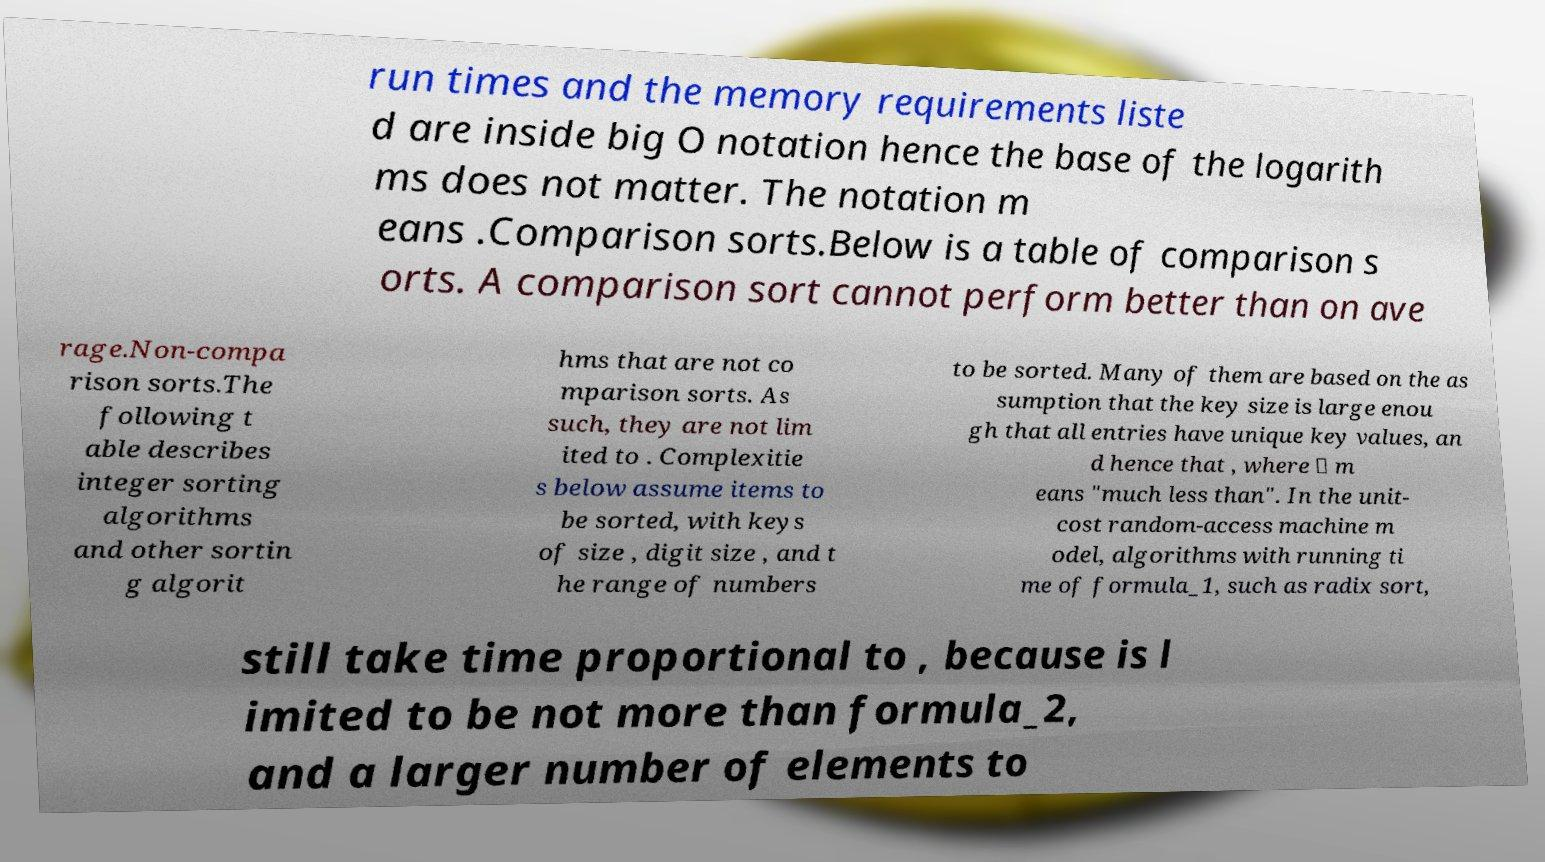Please read and relay the text visible in this image. What does it say? run times and the memory requirements liste d are inside big O notation hence the base of the logarith ms does not matter. The notation m eans .Comparison sorts.Below is a table of comparison s orts. A comparison sort cannot perform better than on ave rage.Non-compa rison sorts.The following t able describes integer sorting algorithms and other sortin g algorit hms that are not co mparison sorts. As such, they are not lim ited to . Complexitie s below assume items to be sorted, with keys of size , digit size , and t he range of numbers to be sorted. Many of them are based on the as sumption that the key size is large enou gh that all entries have unique key values, an d hence that , where ≪ m eans "much less than". In the unit- cost random-access machine m odel, algorithms with running ti me of formula_1, such as radix sort, still take time proportional to , because is l imited to be not more than formula_2, and a larger number of elements to 